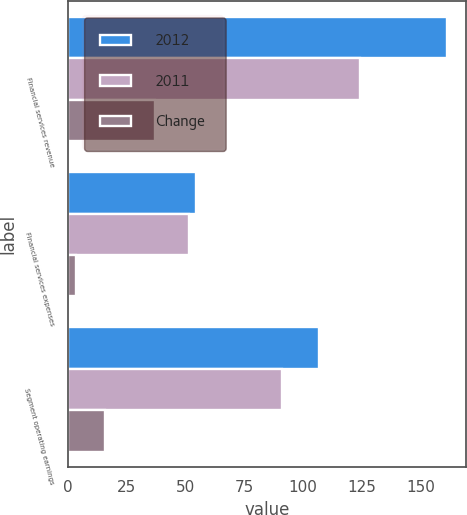<chart> <loc_0><loc_0><loc_500><loc_500><stacked_bar_chart><ecel><fcel>Financial services revenue<fcel>Financial services expenses<fcel>Segment operating earnings<nl><fcel>2012<fcel>161.3<fcel>54.6<fcel>106.7<nl><fcel>2011<fcel>124.3<fcel>51.4<fcel>90.9<nl><fcel>Change<fcel>37<fcel>3.2<fcel>15.8<nl></chart> 